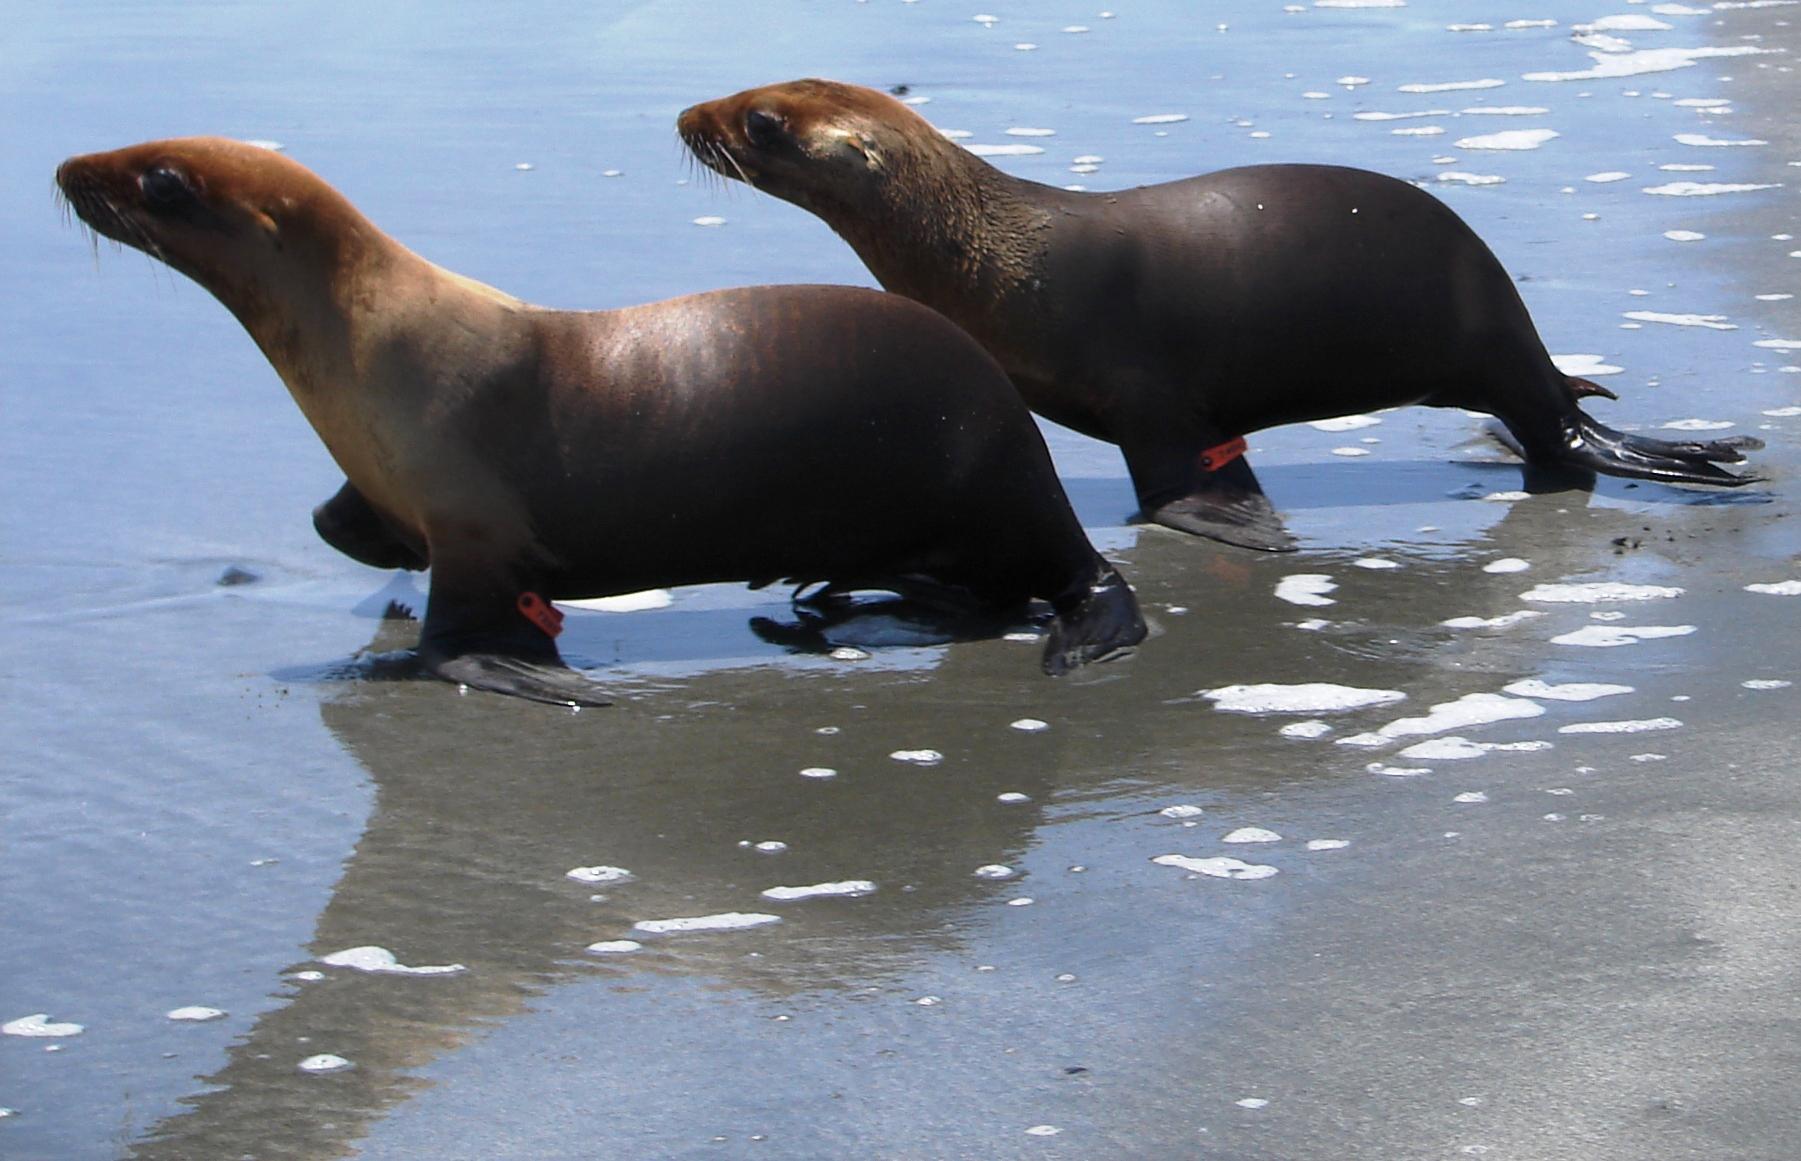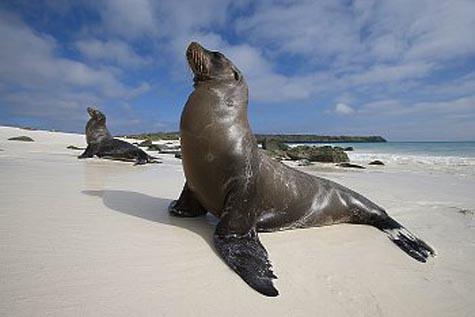The first image is the image on the left, the second image is the image on the right. For the images shown, is this caption "There are two seals in total." true? Answer yes or no. No. The first image is the image on the left, the second image is the image on the right. Examine the images to the left and right. Is the description "An image shows exactly one seal on a manmade structure next to a blue pool." accurate? Answer yes or no. No. 